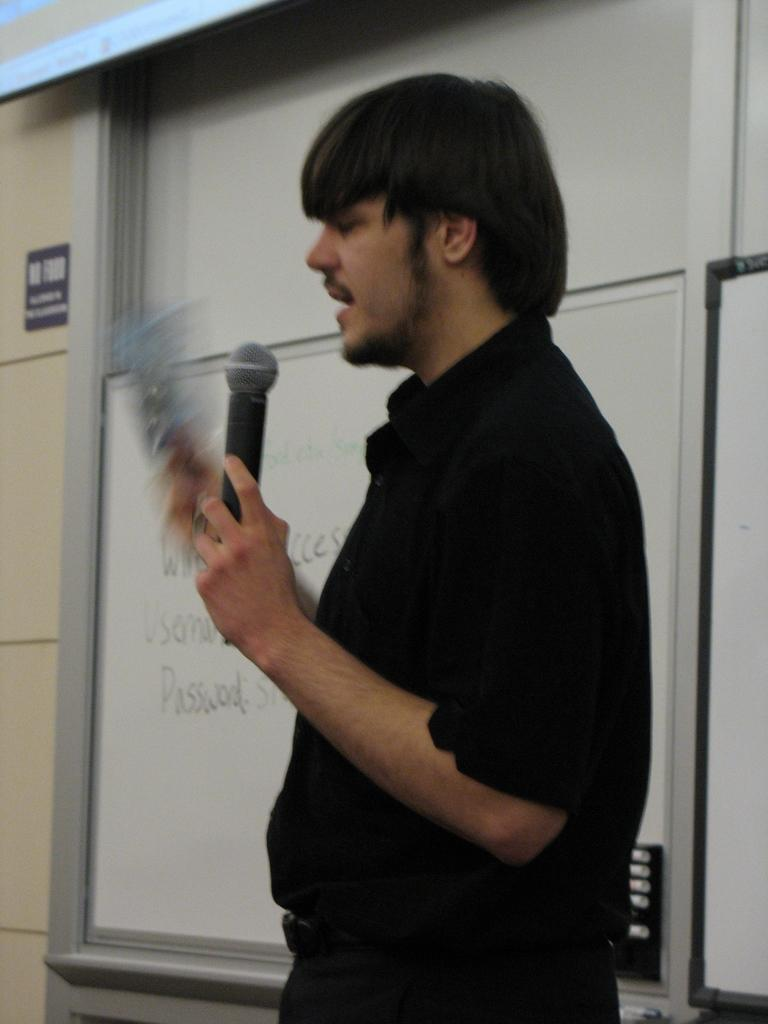Who is the person in the image? There is a man in the image. What is the man wearing? The man is wearing a black shirt. What is the man holding in his hand? The man is holding a microphone in his hand. What object is present in the image that is typically used for writing or displaying information? There is a whiteboard in the image. What might the man be doing based on the presence of the microphone and his appearance? The man appears to be talking, possibly giving a presentation or speech. What type of twist can be seen in the man's hair in the image? There is no twist visible in the man's hair in the image. What role does the cabbage play in the man's speech in the image? There is no cabbage present in the image, and therefore it cannot play a role in the man's speech. 